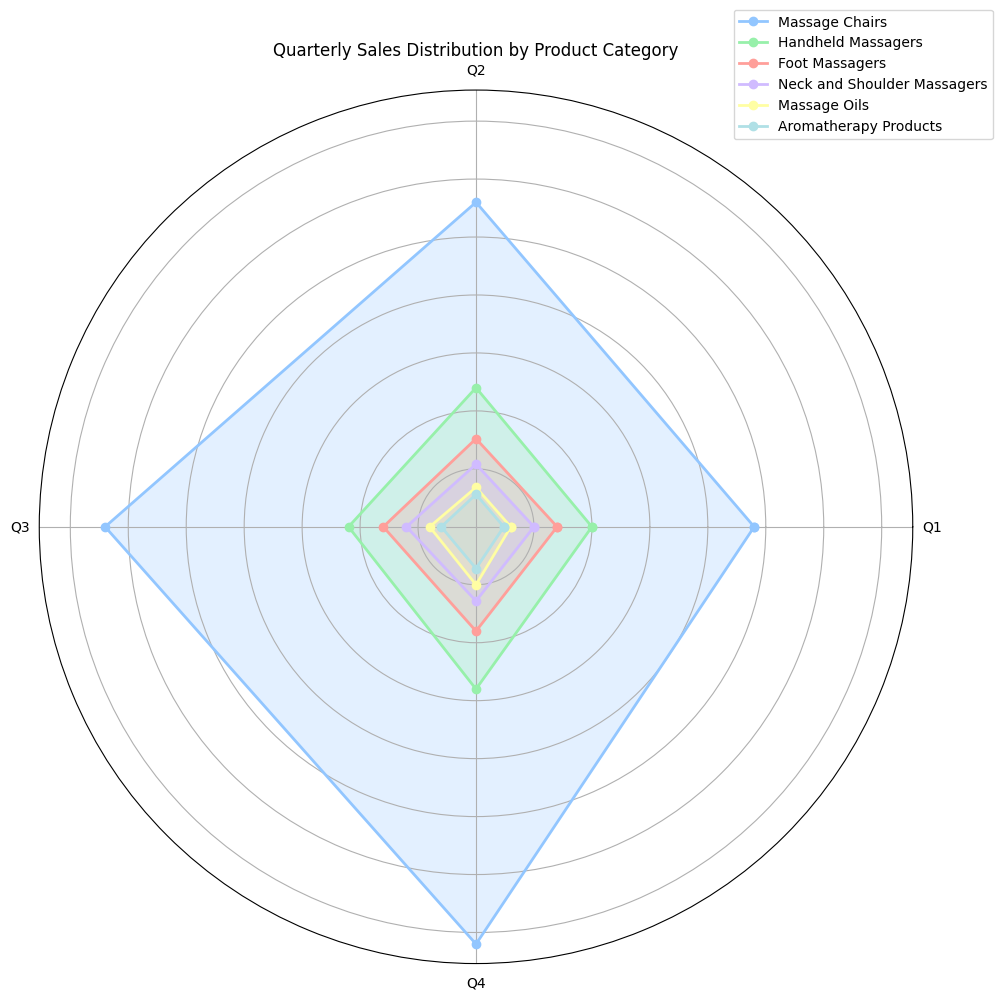What's the total sales for Massage Chairs in all quarters combined? To find the total sales for Massage Chairs, sum the values for each quarter. The sales are 120,000 (Q1) + 140,000 (Q2) + 160,000 (Q3) + 180,000 (Q4) = 600,000.
Answer: 600,000 Which product category had the lowest sales in Q2? By examining the plot, we see the smallest radial distance in Q2 corresponds to Aromatherapy Products, which had sales of 14,000.
Answer: Aromatherapy Products What is the average quarterly sales for Handheld Massagers? To find the average, sum Handheld Massagers' sales over the four quarters and divide by 4. The sales are 50,000 (Q1) + 60,000 (Q2) + 55,000 (Q3) + 70,000 (Q4) = 235,000. The average is 235,000 / 4 = 58,750.
Answer: 58,750 By how much did the sales of Foot Massagers increase from Q1 to Q4? Subtract the sales in Q1 from Q4. The sales were 35,000 in Q1 and 45,000 in Q4. The increase is 45,000 - 35,000 = 10,000.
Answer: 10,000 Which two product categories have the most similar sales figures in Q3? By comparing the lengths of the segments in Q3, Foot Massagers (40,000) and Handheld Massagers (55,000) have the smallest difference, which is 15,000.
Answer: Foot Massagers and Handheld Massagers In which quarter did Neck and Shoulder Massagers see the highest sales? The highest radial distance for Neck and Shoulder Massagers is seen in Q4, where it reached sales of 32,000.
Answer: Q4 If you sum the sales of Aromatherapy Products and Massage Oils in Q1, does the sum exceed the sales of Foot Massagers in the same quarter? Aromatherapy Products in Q1 had 12,000 sales and Massage Oils had 15,000. Their sum is 12,000 + 15,000 = 27,000, which is less than the 35,000 sales of Foot Massagers in Q1.
Answer: No Which product category had the sharpest increase in sales from Q2 to Q3? The greatest increase is observed in Massage Chairs, which went from 140,000 in Q2 to 160,000 in Q3, an increase of 20,000.
Answer: Massage Chairs 